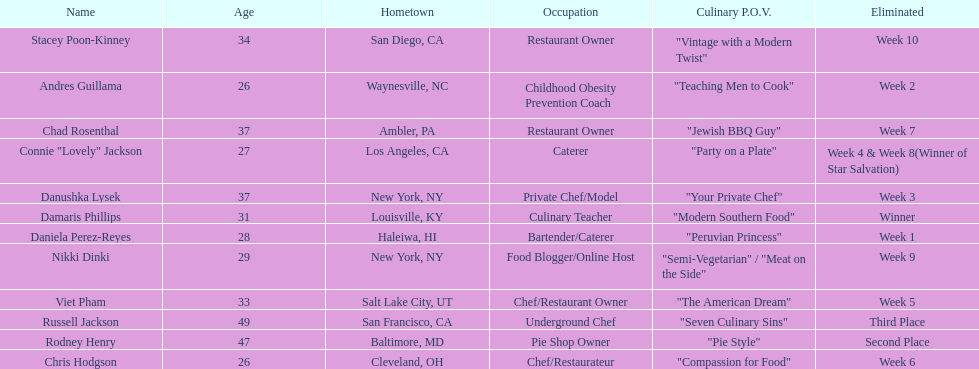Which contestant is the same age as chris hodgson? Andres Guillama. 